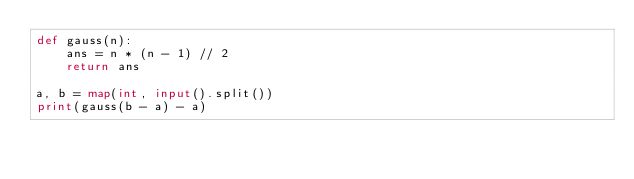<code> <loc_0><loc_0><loc_500><loc_500><_Python_>def gauss(n):
    ans = n * (n - 1) // 2
    return ans

a, b = map(int, input().split())
print(gauss(b - a) - a)

</code> 